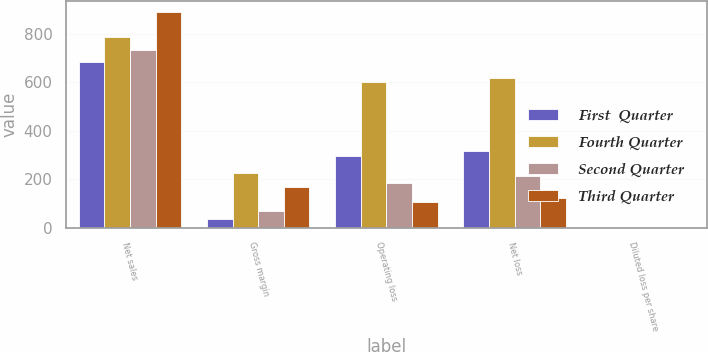Convert chart to OTSL. <chart><loc_0><loc_0><loc_500><loc_500><stacked_bar_chart><ecel><fcel>Net sales<fcel>Gross margin<fcel>Operating loss<fcel>Net loss<fcel>Diluted loss per share<nl><fcel>First  Quarter<fcel>685.1<fcel>37.3<fcel>296.6<fcel>315.9<fcel>0.52<nl><fcel>Fourth Quarter<fcel>785<fcel>223.9<fcel>600.6<fcel>619.2<fcel>1.02<nl><fcel>Second Quarter<fcel>732.7<fcel>71<fcel>183.7<fcel>214.9<fcel>0.36<nl><fcel>Third Quarter<fcel>888.5<fcel>169.5<fcel>105.6<fcel>123.2<fcel>0.2<nl></chart> 